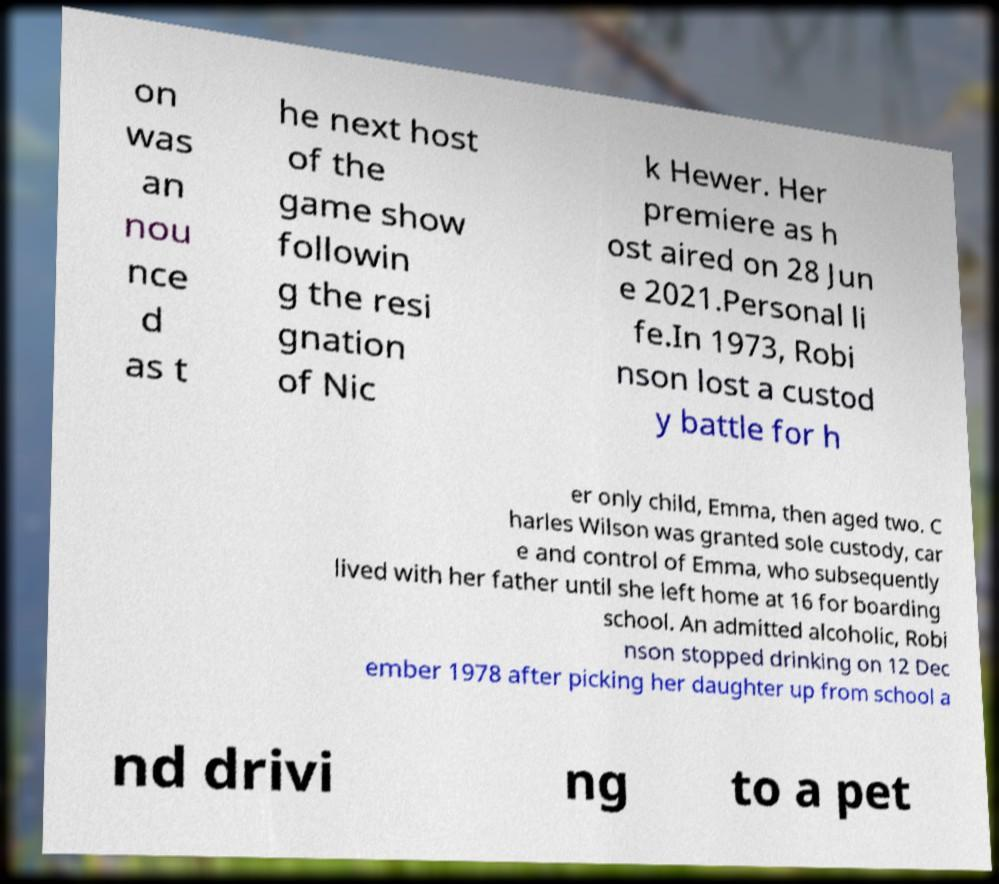Could you assist in decoding the text presented in this image and type it out clearly? on was an nou nce d as t he next host of the game show followin g the resi gnation of Nic k Hewer. Her premiere as h ost aired on 28 Jun e 2021.Personal li fe.In 1973, Robi nson lost a custod y battle for h er only child, Emma, then aged two. C harles Wilson was granted sole custody, car e and control of Emma, who subsequently lived with her father until she left home at 16 for boarding school. An admitted alcoholic, Robi nson stopped drinking on 12 Dec ember 1978 after picking her daughter up from school a nd drivi ng to a pet 